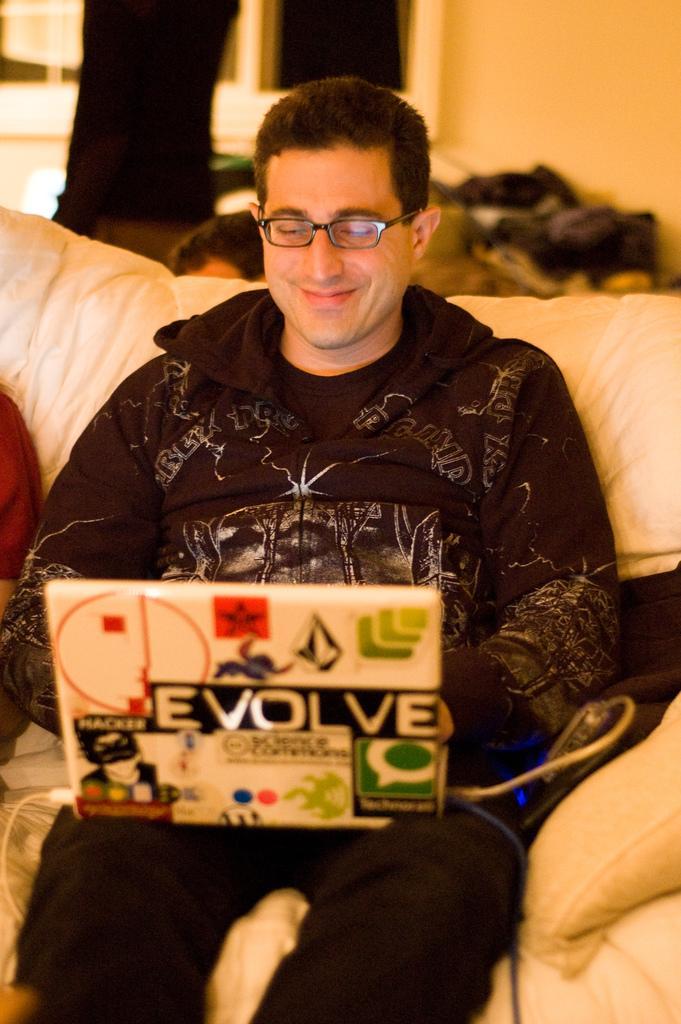Could you give a brief overview of what you see in this image? This picture seems to be clicked inside the room. In the foreground we can see a person sitting on a couch, smiling and seems to be working on a laptop and we can see the text and the depictions of some objects on the laptop. In the background we can see the wall, window, a person like thing and some objects. In the left corner we can see another person seems to be sitting on the couch. 